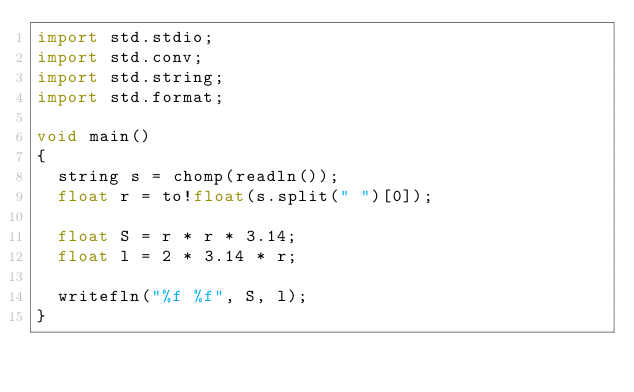<code> <loc_0><loc_0><loc_500><loc_500><_D_>import std.stdio;
import std.conv;
import std.string;
import std.format;

void main()
{
  string s = chomp(readln());
  float r = to!float(s.split(" ")[0]);

  float S = r * r * 3.14;
  float l = 2 * 3.14 * r;

  writefln("%f %f", S, l);
}</code> 